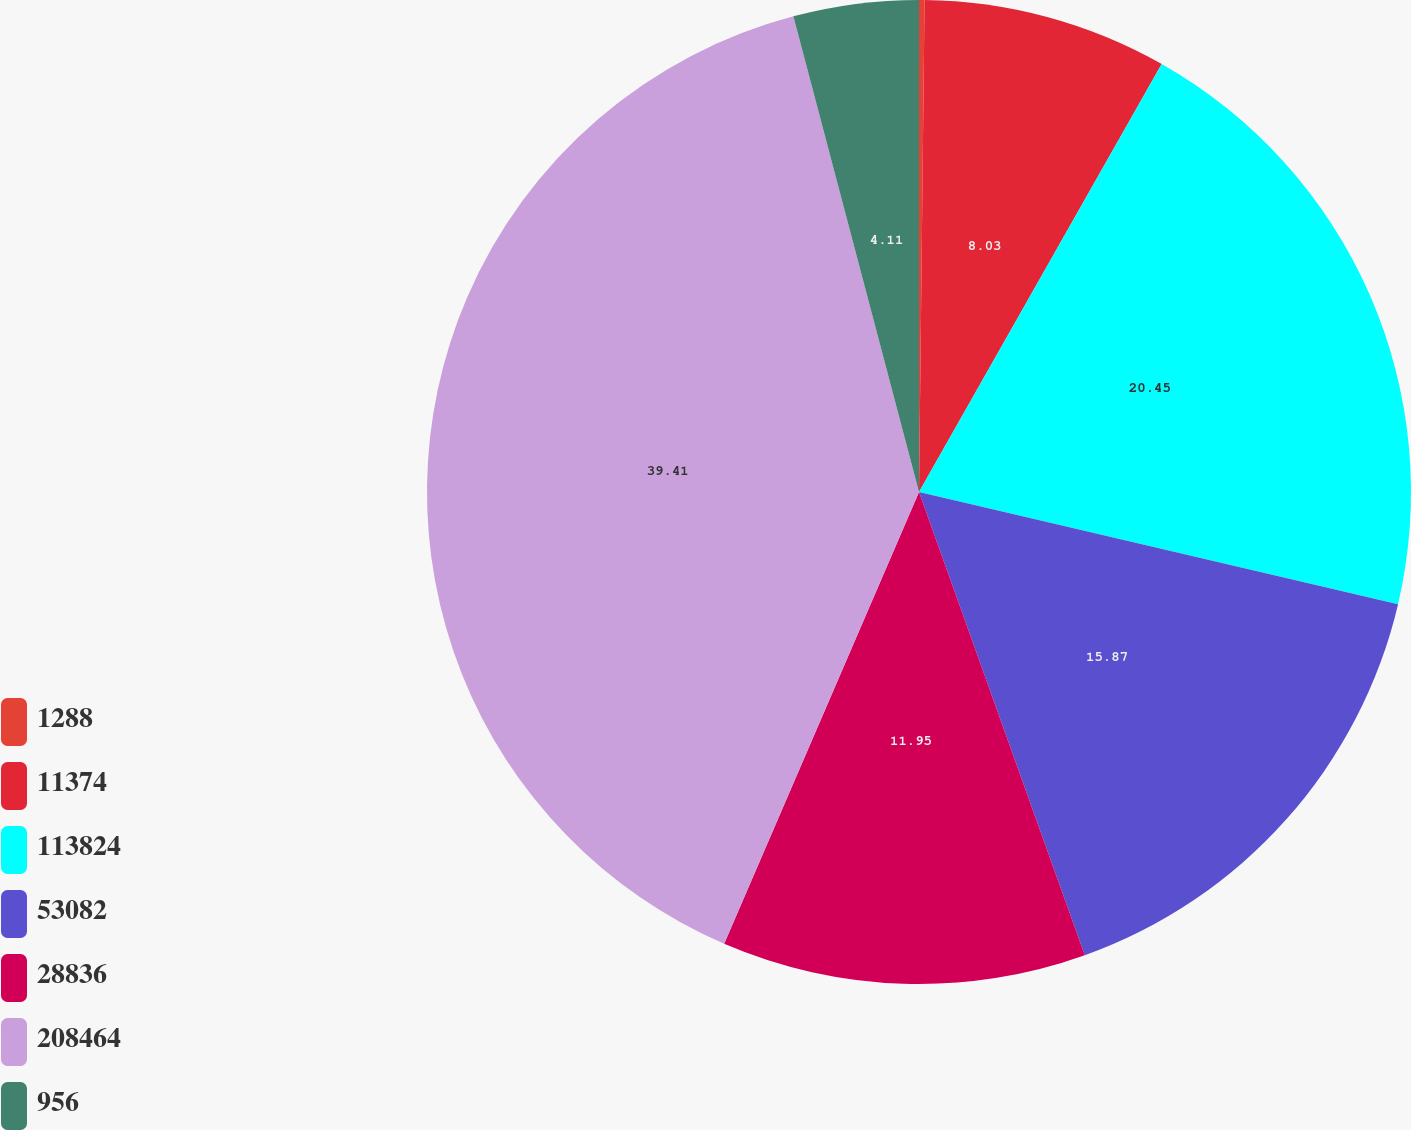<chart> <loc_0><loc_0><loc_500><loc_500><pie_chart><fcel>1288<fcel>11374<fcel>113824<fcel>53082<fcel>28836<fcel>208464<fcel>956<nl><fcel>0.18%<fcel>8.03%<fcel>20.45%<fcel>15.87%<fcel>11.95%<fcel>39.41%<fcel>4.11%<nl></chart> 